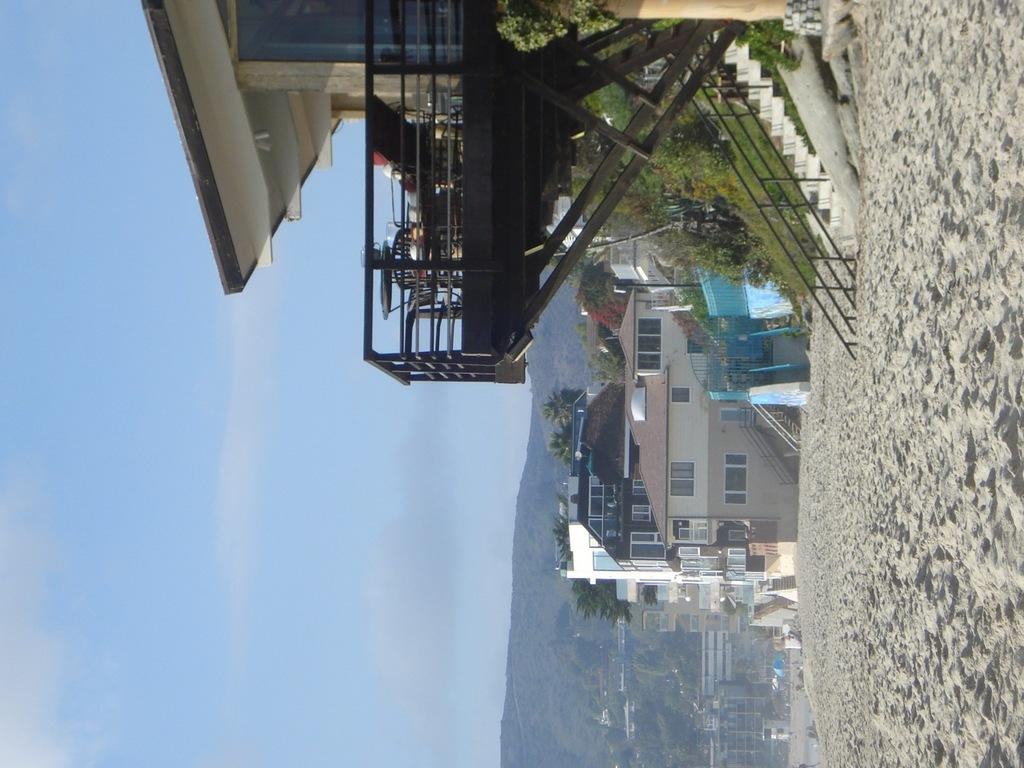What can be seen under the feet of the people in the image? The ground is visible in the image. What type of structures are present in the image? There are buildings with windows in the image. What architectural feature allows for vertical movement in the image? Stairs are present in the image. What safety feature is present near the stairs in the image? Railing is visible in the image. What type of furniture is present in the image? Chairs are present in the image. What type of surface is available for placing objects in the image? There is a table in the image. What type of vegetation is present in the image? Trees and plants are visible in the image. What part of the natural environment is visible in the image? The sky is visible in the image. What atmospheric feature can be seen in the sky? Clouds are present in the sky. Can you hear the minister playing the horn while driving in the image? There is no minister, horn, or driving present in the image. 